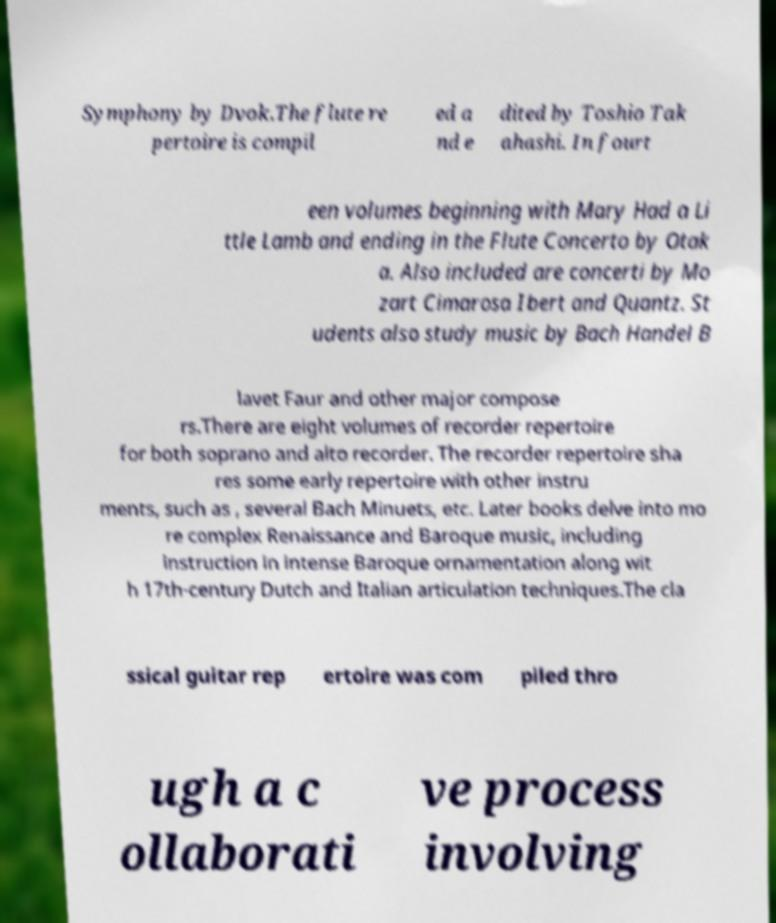For documentation purposes, I need the text within this image transcribed. Could you provide that? Symphony by Dvok.The flute re pertoire is compil ed a nd e dited by Toshio Tak ahashi. In fourt een volumes beginning with Mary Had a Li ttle Lamb and ending in the Flute Concerto by Otak a. Also included are concerti by Mo zart Cimarosa Ibert and Quantz. St udents also study music by Bach Handel B lavet Faur and other major compose rs.There are eight volumes of recorder repertoire for both soprano and alto recorder. The recorder repertoire sha res some early repertoire with other instru ments, such as , several Bach Minuets, etc. Later books delve into mo re complex Renaissance and Baroque music, including instruction in intense Baroque ornamentation along wit h 17th-century Dutch and Italian articulation techniques.The cla ssical guitar rep ertoire was com piled thro ugh a c ollaborati ve process involving 